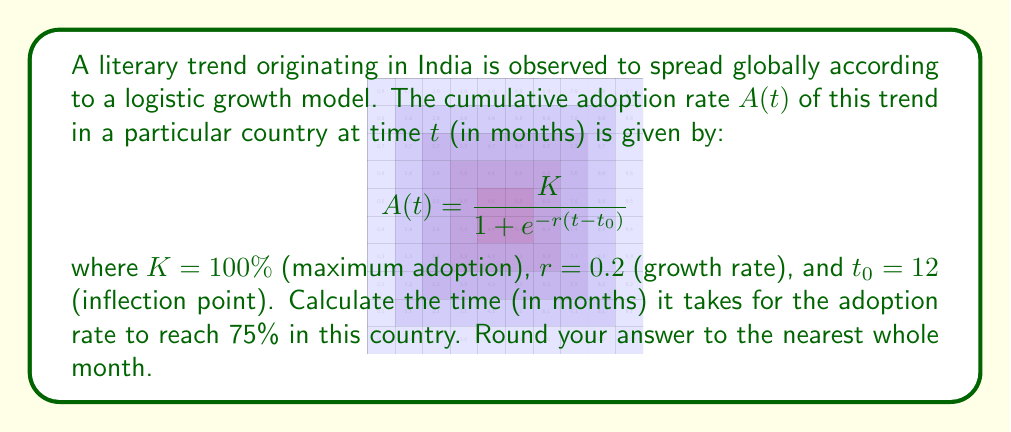Show me your answer to this math problem. To solve this problem, we'll follow these steps:

1) We need to find $t$ when $A(t) = 75\%$. Let's substitute the known values into the equation:

   $$0.75 = \frac{1}{1 + e^{-0.2(t-12)}}$$

2) Multiply both sides by the denominator:

   $$0.75(1 + e^{-0.2(t-12)}) = 1$$

3) Distribute on the left side:

   $$0.75 + 0.75e^{-0.2(t-12)} = 1$$

4) Subtract 0.75 from both sides:

   $$0.75e^{-0.2(t-12)} = 0.25$$

5) Divide both sides by 0.75:

   $$e^{-0.2(t-12)} = \frac{1}{3}$$

6) Take the natural log of both sides:

   $$-0.2(t-12) = \ln(\frac{1}{3})$$

7) Divide both sides by -0.2:

   $$t-12 = -\frac{\ln(\frac{1}{3})}{0.2}$$

8) Add 12 to both sides:

   $$t = 12 - \frac{\ln(\frac{1}{3})}{0.2}$$

9) Calculate the result:

   $$t \approx 12 + 5.4954 \approx 17.4954$$

10) Rounding to the nearest whole month:

    $t \approx 17$ months
Answer: 17 months 